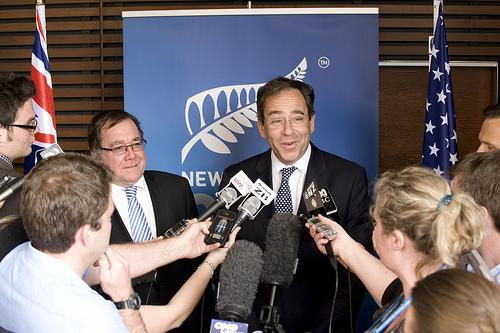Identify the two main figures in the image and their clothing. The two main figures are a man wearing a dark jacket and black and white tie, and another man in a dark suit with a blue and white striped tie. What objects can be seen in the image with respect to the man being interviewed? Next to the man being interviewed are an American flag and a British flag, as well as microphones being held by people and a blue sign with white lettering and logo in the background. Describe the sentiments and atmosphere conveyed by the image. The image conveys a serious atmosphere with focused attention on the main subject, as the press members are actively asking questions and recording the responses of the man being interviewed. What type of event is happening in the image, and who is the main focus? A press conference is happening in the image, and the main focus is on a man in a dark jacket who is speaking to the press. What is the role of the people accompanying the main subject in the image? The people accompanying the main subject are members of the press asking questions and interviewing the man, while some are holding microphones and recorders. Describe the scene taking place in the image. There is a man wearing a dark jacket being interviewed by members of the press, with several microphones in his face, and an American and UK flag in the background. Given the provided details, find the relation between the two men being interviewed. One man is speaking to the press, and the other man is standing next to him. What do the men who are being interviewed have in common in the form of an accessory? Both men are wearing neckties. What is the profession of the woman with blonde hair? A member of the press How many types of microphones can you identify in the image? Three types: handheld microphones, a large boom microphone, and a black mic with a furry cover. Do the man and woman holding recorders belong to the same profession? Yes, they are both members of the press. Identify two types of neckties mentioned in the image. navy necktie with white spots, blue and white striped necktie What is happening to the man with several microphones around him? He is being interviewed by the press. What is the man in the striped tie doing in the image? He is standing next to the man speaking to the press. What color is the jacket of the man speaking into the microphones? Black What is the activity taking place between the group of people and the man? They are asking him questions during an interview. Identify the flags standing in the background of the press conference. An American flag and a UK flag Is there any window in the photo? What is on it? Yes, there is a window with brown blinds. Which of these best describes the woman with a ponytail? (A) Woman holding a smartphone (B) Woman holding a microphone and recorder (C) Woman holding a boom microphone (B) Woman holding a microphone and recorder Some people at the event are wearing accessories. Describe two such accessories present. A watch on a man's right wrist and a man wearing clear eyeglasses. What color is the background sign, and does it contain any symbols? The sign is blue and white, with a trademark symbol on it. Find the common element shared by the people holding microphones. They are all members of the press. Which flag stands next to the man being interviewed? American flag There is a sign in the background. What color is it and what does it have on it? The sign is blue and white with white lettering and a logo. A man is holding a device while speaking to the press. What is the device? It is a smartphone used for recording. 